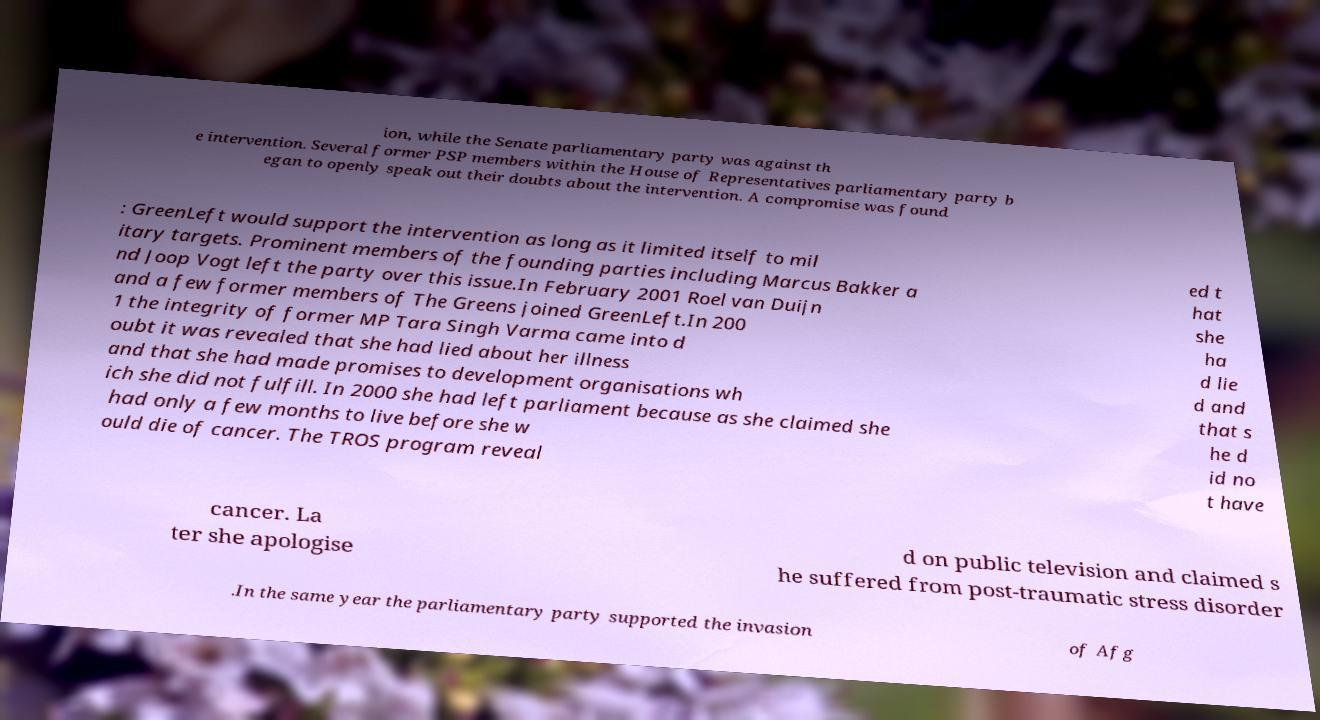There's text embedded in this image that I need extracted. Can you transcribe it verbatim? ion, while the Senate parliamentary party was against th e intervention. Several former PSP members within the House of Representatives parliamentary party b egan to openly speak out their doubts about the intervention. A compromise was found : GreenLeft would support the intervention as long as it limited itself to mil itary targets. Prominent members of the founding parties including Marcus Bakker a nd Joop Vogt left the party over this issue.In February 2001 Roel van Duijn and a few former members of The Greens joined GreenLeft.In 200 1 the integrity of former MP Tara Singh Varma came into d oubt it was revealed that she had lied about her illness and that she had made promises to development organisations wh ich she did not fulfill. In 2000 she had left parliament because as she claimed she had only a few months to live before she w ould die of cancer. The TROS program reveal ed t hat she ha d lie d and that s he d id no t have cancer. La ter she apologise d on public television and claimed s he suffered from post-traumatic stress disorder .In the same year the parliamentary party supported the invasion of Afg 